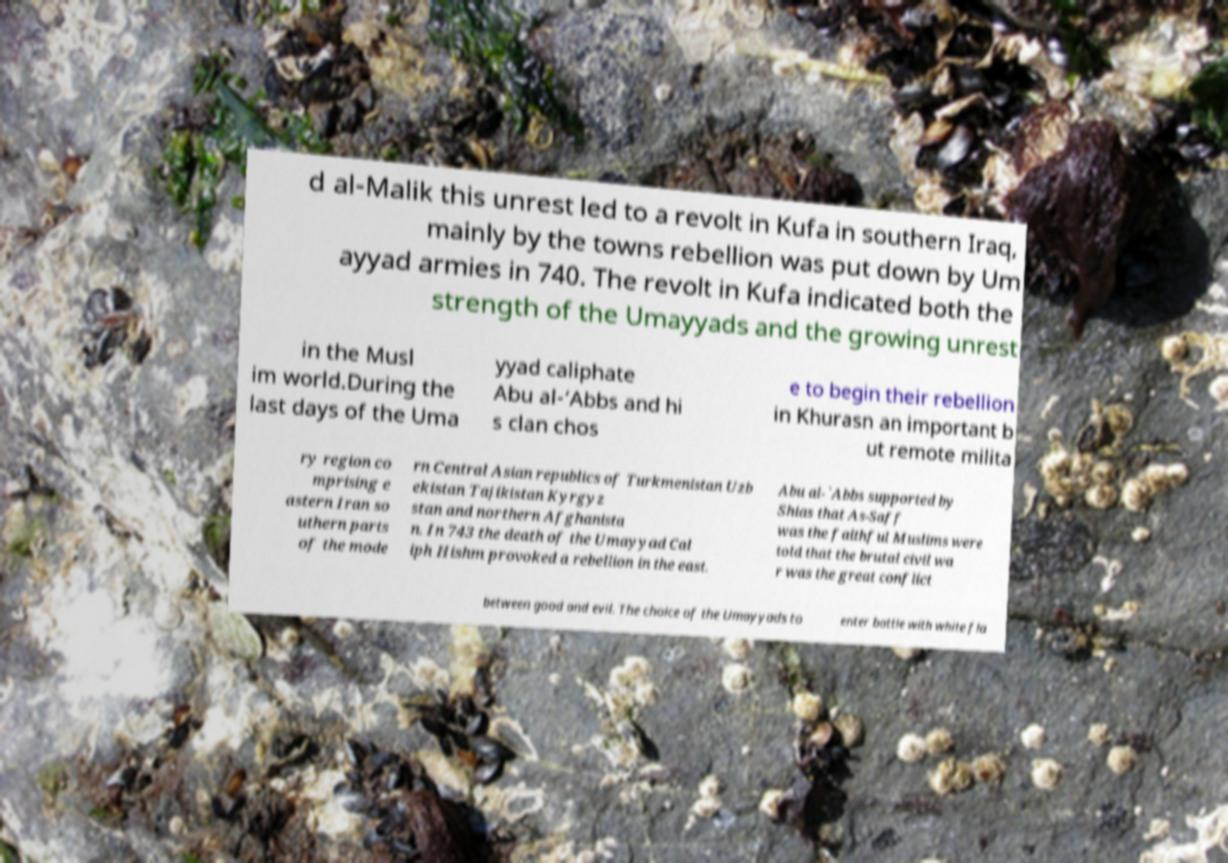Could you assist in decoding the text presented in this image and type it out clearly? d al-Malik this unrest led to a revolt in Kufa in southern Iraq, mainly by the towns rebellion was put down by Um ayyad armies in 740. The revolt in Kufa indicated both the strength of the Umayyads and the growing unrest in the Musl im world.During the last days of the Uma yyad caliphate Abu al-‘Abbs and hi s clan chos e to begin their rebellion in Khurasn an important b ut remote milita ry region co mprising e astern Iran so uthern parts of the mode rn Central Asian republics of Turkmenistan Uzb ekistan Tajikistan Kyrgyz stan and northern Afghanista n. In 743 the death of the Umayyad Cal iph Hishm provoked a rebellion in the east. Abu al-`Abbs supported by Shias that As-Saff was the faithful Muslims were told that the brutal civil wa r was the great conflict between good and evil. The choice of the Umayyads to enter battle with white fla 